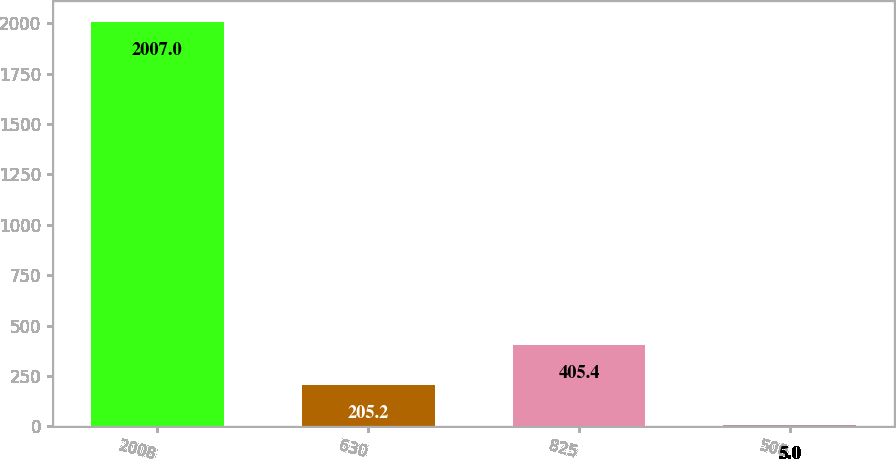Convert chart to OTSL. <chart><loc_0><loc_0><loc_500><loc_500><bar_chart><fcel>2008<fcel>630<fcel>825<fcel>500<nl><fcel>2007<fcel>205.2<fcel>405.4<fcel>5<nl></chart> 